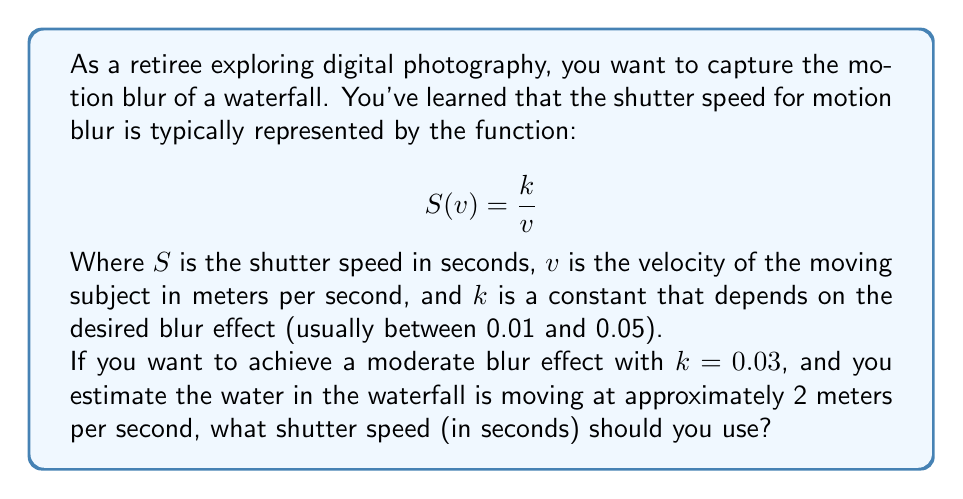What is the answer to this math problem? To solve this problem, we need to use the given function and substitute the known values:

1. The function for shutter speed is: $S(v) = \frac{k}{v}$

2. We're given:
   - $k = 0.03$ (for moderate blur effect)
   - $v = 2$ meters per second (estimated water velocity)

3. Let's substitute these values into the function:

   $$S(2) = \frac{0.03}{2}$$

4. Now we can simplify:
   
   $$S(2) = 0.015$$

5. Therefore, the optimal shutter speed for capturing motion blur in this scenario is 0.015 seconds, or 1/67th of a second when rounded to the nearest common shutter speed fraction.

This slower shutter speed will allow the moving water to create a blurred effect in the photograph, while still maintaining some detail in the stationary elements of the scene.
Answer: 0.015 seconds (approximately 1/67th of a second) 